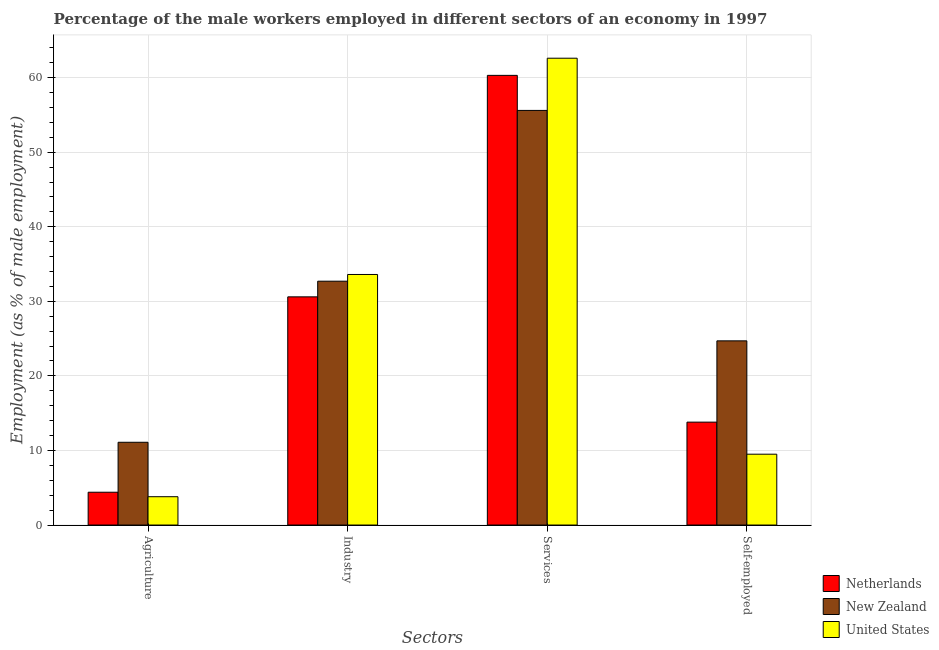How many different coloured bars are there?
Offer a very short reply. 3. Are the number of bars per tick equal to the number of legend labels?
Keep it short and to the point. Yes. How many bars are there on the 3rd tick from the left?
Provide a short and direct response. 3. How many bars are there on the 2nd tick from the right?
Make the answer very short. 3. What is the label of the 4th group of bars from the left?
Give a very brief answer. Self-employed. What is the percentage of male workers in services in New Zealand?
Provide a short and direct response. 55.6. Across all countries, what is the maximum percentage of self employed male workers?
Offer a terse response. 24.7. Across all countries, what is the minimum percentage of male workers in services?
Provide a succinct answer. 55.6. In which country was the percentage of male workers in agriculture maximum?
Keep it short and to the point. New Zealand. In which country was the percentage of male workers in services minimum?
Your answer should be compact. New Zealand. What is the total percentage of male workers in industry in the graph?
Provide a short and direct response. 96.9. What is the difference between the percentage of male workers in agriculture in New Zealand and that in United States?
Give a very brief answer. 7.3. What is the difference between the percentage of self employed male workers in United States and the percentage of male workers in agriculture in New Zealand?
Your response must be concise. -1.6. What is the average percentage of male workers in industry per country?
Give a very brief answer. 32.3. What is the difference between the percentage of male workers in services and percentage of self employed male workers in United States?
Offer a very short reply. 53.1. What is the ratio of the percentage of male workers in agriculture in United States to that in New Zealand?
Provide a succinct answer. 0.34. What is the difference between the highest and the second highest percentage of male workers in services?
Your answer should be very brief. 2.3. What is the difference between the highest and the lowest percentage of self employed male workers?
Ensure brevity in your answer.  15.2. Is it the case that in every country, the sum of the percentage of male workers in agriculture and percentage of self employed male workers is greater than the sum of percentage of male workers in services and percentage of male workers in industry?
Provide a short and direct response. No. What does the 2nd bar from the left in Self-employed represents?
Keep it short and to the point. New Zealand. What does the 2nd bar from the right in Self-employed represents?
Your answer should be compact. New Zealand. How many bars are there?
Offer a terse response. 12. Are the values on the major ticks of Y-axis written in scientific E-notation?
Your response must be concise. No. Does the graph contain any zero values?
Give a very brief answer. No. How are the legend labels stacked?
Provide a short and direct response. Vertical. What is the title of the graph?
Your answer should be compact. Percentage of the male workers employed in different sectors of an economy in 1997. What is the label or title of the X-axis?
Provide a succinct answer. Sectors. What is the label or title of the Y-axis?
Your answer should be compact. Employment (as % of male employment). What is the Employment (as % of male employment) in Netherlands in Agriculture?
Offer a terse response. 4.4. What is the Employment (as % of male employment) of New Zealand in Agriculture?
Your response must be concise. 11.1. What is the Employment (as % of male employment) of United States in Agriculture?
Make the answer very short. 3.8. What is the Employment (as % of male employment) of Netherlands in Industry?
Your response must be concise. 30.6. What is the Employment (as % of male employment) of New Zealand in Industry?
Make the answer very short. 32.7. What is the Employment (as % of male employment) of United States in Industry?
Make the answer very short. 33.6. What is the Employment (as % of male employment) of Netherlands in Services?
Keep it short and to the point. 60.3. What is the Employment (as % of male employment) in New Zealand in Services?
Offer a terse response. 55.6. What is the Employment (as % of male employment) of United States in Services?
Keep it short and to the point. 62.6. What is the Employment (as % of male employment) in Netherlands in Self-employed?
Provide a short and direct response. 13.8. What is the Employment (as % of male employment) in New Zealand in Self-employed?
Your answer should be compact. 24.7. Across all Sectors, what is the maximum Employment (as % of male employment) of Netherlands?
Provide a succinct answer. 60.3. Across all Sectors, what is the maximum Employment (as % of male employment) of New Zealand?
Provide a succinct answer. 55.6. Across all Sectors, what is the maximum Employment (as % of male employment) in United States?
Give a very brief answer. 62.6. Across all Sectors, what is the minimum Employment (as % of male employment) in Netherlands?
Provide a succinct answer. 4.4. Across all Sectors, what is the minimum Employment (as % of male employment) of New Zealand?
Ensure brevity in your answer.  11.1. Across all Sectors, what is the minimum Employment (as % of male employment) of United States?
Your answer should be compact. 3.8. What is the total Employment (as % of male employment) in Netherlands in the graph?
Your answer should be very brief. 109.1. What is the total Employment (as % of male employment) of New Zealand in the graph?
Your answer should be compact. 124.1. What is the total Employment (as % of male employment) of United States in the graph?
Your response must be concise. 109.5. What is the difference between the Employment (as % of male employment) of Netherlands in Agriculture and that in Industry?
Keep it short and to the point. -26.2. What is the difference between the Employment (as % of male employment) of New Zealand in Agriculture and that in Industry?
Give a very brief answer. -21.6. What is the difference between the Employment (as % of male employment) of United States in Agriculture and that in Industry?
Offer a terse response. -29.8. What is the difference between the Employment (as % of male employment) of Netherlands in Agriculture and that in Services?
Offer a very short reply. -55.9. What is the difference between the Employment (as % of male employment) of New Zealand in Agriculture and that in Services?
Offer a terse response. -44.5. What is the difference between the Employment (as % of male employment) of United States in Agriculture and that in Services?
Offer a very short reply. -58.8. What is the difference between the Employment (as % of male employment) in New Zealand in Agriculture and that in Self-employed?
Keep it short and to the point. -13.6. What is the difference between the Employment (as % of male employment) of United States in Agriculture and that in Self-employed?
Ensure brevity in your answer.  -5.7. What is the difference between the Employment (as % of male employment) of Netherlands in Industry and that in Services?
Ensure brevity in your answer.  -29.7. What is the difference between the Employment (as % of male employment) in New Zealand in Industry and that in Services?
Your answer should be very brief. -22.9. What is the difference between the Employment (as % of male employment) in United States in Industry and that in Services?
Keep it short and to the point. -29. What is the difference between the Employment (as % of male employment) in New Zealand in Industry and that in Self-employed?
Your answer should be very brief. 8. What is the difference between the Employment (as % of male employment) in United States in Industry and that in Self-employed?
Keep it short and to the point. 24.1. What is the difference between the Employment (as % of male employment) in Netherlands in Services and that in Self-employed?
Your response must be concise. 46.5. What is the difference between the Employment (as % of male employment) of New Zealand in Services and that in Self-employed?
Your answer should be very brief. 30.9. What is the difference between the Employment (as % of male employment) in United States in Services and that in Self-employed?
Ensure brevity in your answer.  53.1. What is the difference between the Employment (as % of male employment) of Netherlands in Agriculture and the Employment (as % of male employment) of New Zealand in Industry?
Your answer should be compact. -28.3. What is the difference between the Employment (as % of male employment) of Netherlands in Agriculture and the Employment (as % of male employment) of United States in Industry?
Offer a very short reply. -29.2. What is the difference between the Employment (as % of male employment) of New Zealand in Agriculture and the Employment (as % of male employment) of United States in Industry?
Offer a very short reply. -22.5. What is the difference between the Employment (as % of male employment) of Netherlands in Agriculture and the Employment (as % of male employment) of New Zealand in Services?
Your answer should be compact. -51.2. What is the difference between the Employment (as % of male employment) in Netherlands in Agriculture and the Employment (as % of male employment) in United States in Services?
Your answer should be compact. -58.2. What is the difference between the Employment (as % of male employment) in New Zealand in Agriculture and the Employment (as % of male employment) in United States in Services?
Your answer should be very brief. -51.5. What is the difference between the Employment (as % of male employment) of Netherlands in Agriculture and the Employment (as % of male employment) of New Zealand in Self-employed?
Provide a succinct answer. -20.3. What is the difference between the Employment (as % of male employment) in Netherlands in Agriculture and the Employment (as % of male employment) in United States in Self-employed?
Provide a succinct answer. -5.1. What is the difference between the Employment (as % of male employment) in New Zealand in Agriculture and the Employment (as % of male employment) in United States in Self-employed?
Your answer should be compact. 1.6. What is the difference between the Employment (as % of male employment) in Netherlands in Industry and the Employment (as % of male employment) in New Zealand in Services?
Your answer should be compact. -25. What is the difference between the Employment (as % of male employment) in Netherlands in Industry and the Employment (as % of male employment) in United States in Services?
Make the answer very short. -32. What is the difference between the Employment (as % of male employment) in New Zealand in Industry and the Employment (as % of male employment) in United States in Services?
Your answer should be very brief. -29.9. What is the difference between the Employment (as % of male employment) of Netherlands in Industry and the Employment (as % of male employment) of United States in Self-employed?
Your answer should be very brief. 21.1. What is the difference between the Employment (as % of male employment) in New Zealand in Industry and the Employment (as % of male employment) in United States in Self-employed?
Give a very brief answer. 23.2. What is the difference between the Employment (as % of male employment) in Netherlands in Services and the Employment (as % of male employment) in New Zealand in Self-employed?
Your response must be concise. 35.6. What is the difference between the Employment (as % of male employment) of Netherlands in Services and the Employment (as % of male employment) of United States in Self-employed?
Your answer should be compact. 50.8. What is the difference between the Employment (as % of male employment) of New Zealand in Services and the Employment (as % of male employment) of United States in Self-employed?
Your answer should be compact. 46.1. What is the average Employment (as % of male employment) of Netherlands per Sectors?
Ensure brevity in your answer.  27.27. What is the average Employment (as % of male employment) of New Zealand per Sectors?
Your answer should be compact. 31.02. What is the average Employment (as % of male employment) in United States per Sectors?
Your response must be concise. 27.38. What is the difference between the Employment (as % of male employment) of Netherlands and Employment (as % of male employment) of New Zealand in Agriculture?
Keep it short and to the point. -6.7. What is the difference between the Employment (as % of male employment) of Netherlands and Employment (as % of male employment) of New Zealand in Industry?
Your answer should be compact. -2.1. What is the difference between the Employment (as % of male employment) of New Zealand and Employment (as % of male employment) of United States in Industry?
Your answer should be compact. -0.9. What is the difference between the Employment (as % of male employment) of Netherlands and Employment (as % of male employment) of New Zealand in Services?
Keep it short and to the point. 4.7. What is the difference between the Employment (as % of male employment) in Netherlands and Employment (as % of male employment) in United States in Services?
Provide a short and direct response. -2.3. What is the difference between the Employment (as % of male employment) of Netherlands and Employment (as % of male employment) of New Zealand in Self-employed?
Offer a very short reply. -10.9. What is the difference between the Employment (as % of male employment) in Netherlands and Employment (as % of male employment) in United States in Self-employed?
Your answer should be compact. 4.3. What is the ratio of the Employment (as % of male employment) of Netherlands in Agriculture to that in Industry?
Offer a terse response. 0.14. What is the ratio of the Employment (as % of male employment) in New Zealand in Agriculture to that in Industry?
Offer a very short reply. 0.34. What is the ratio of the Employment (as % of male employment) in United States in Agriculture to that in Industry?
Provide a succinct answer. 0.11. What is the ratio of the Employment (as % of male employment) of Netherlands in Agriculture to that in Services?
Your response must be concise. 0.07. What is the ratio of the Employment (as % of male employment) of New Zealand in Agriculture to that in Services?
Provide a succinct answer. 0.2. What is the ratio of the Employment (as % of male employment) in United States in Agriculture to that in Services?
Offer a terse response. 0.06. What is the ratio of the Employment (as % of male employment) in Netherlands in Agriculture to that in Self-employed?
Make the answer very short. 0.32. What is the ratio of the Employment (as % of male employment) in New Zealand in Agriculture to that in Self-employed?
Provide a succinct answer. 0.45. What is the ratio of the Employment (as % of male employment) of Netherlands in Industry to that in Services?
Ensure brevity in your answer.  0.51. What is the ratio of the Employment (as % of male employment) of New Zealand in Industry to that in Services?
Offer a terse response. 0.59. What is the ratio of the Employment (as % of male employment) of United States in Industry to that in Services?
Keep it short and to the point. 0.54. What is the ratio of the Employment (as % of male employment) of Netherlands in Industry to that in Self-employed?
Your answer should be very brief. 2.22. What is the ratio of the Employment (as % of male employment) of New Zealand in Industry to that in Self-employed?
Your response must be concise. 1.32. What is the ratio of the Employment (as % of male employment) of United States in Industry to that in Self-employed?
Offer a terse response. 3.54. What is the ratio of the Employment (as % of male employment) of Netherlands in Services to that in Self-employed?
Give a very brief answer. 4.37. What is the ratio of the Employment (as % of male employment) of New Zealand in Services to that in Self-employed?
Make the answer very short. 2.25. What is the ratio of the Employment (as % of male employment) in United States in Services to that in Self-employed?
Provide a succinct answer. 6.59. What is the difference between the highest and the second highest Employment (as % of male employment) of Netherlands?
Provide a succinct answer. 29.7. What is the difference between the highest and the second highest Employment (as % of male employment) of New Zealand?
Make the answer very short. 22.9. What is the difference between the highest and the lowest Employment (as % of male employment) in Netherlands?
Your response must be concise. 55.9. What is the difference between the highest and the lowest Employment (as % of male employment) in New Zealand?
Provide a short and direct response. 44.5. What is the difference between the highest and the lowest Employment (as % of male employment) in United States?
Keep it short and to the point. 58.8. 